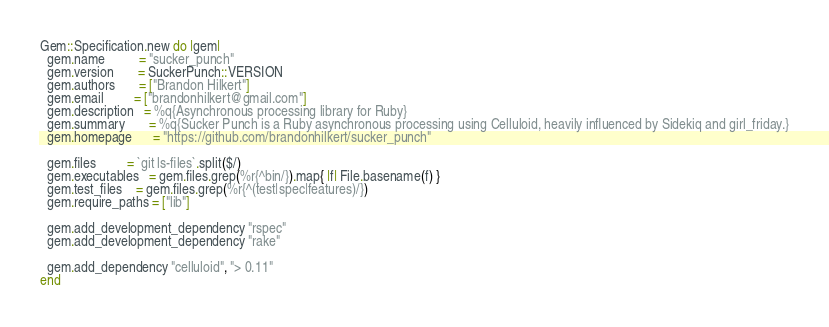<code> <loc_0><loc_0><loc_500><loc_500><_Ruby_>Gem::Specification.new do |gem|
  gem.name          = "sucker_punch"
  gem.version       = SuckerPunch::VERSION
  gem.authors       = ["Brandon Hilkert"]
  gem.email         = ["brandonhilkert@gmail.com"]
  gem.description   = %q{Asynchronous processing library for Ruby}
  gem.summary       = %q{Sucker Punch is a Ruby asynchronous processing using Celluloid, heavily influenced by Sidekiq and girl_friday.}
  gem.homepage      = "https://github.com/brandonhilkert/sucker_punch"

  gem.files         = `git ls-files`.split($/)
  gem.executables   = gem.files.grep(%r{^bin/}).map{ |f| File.basename(f) }
  gem.test_files    = gem.files.grep(%r{^(test|spec|features)/})
  gem.require_paths = ["lib"]

  gem.add_development_dependency "rspec"
  gem.add_development_dependency "rake"

  gem.add_dependency "celluloid", "> 0.11"
end
</code> 